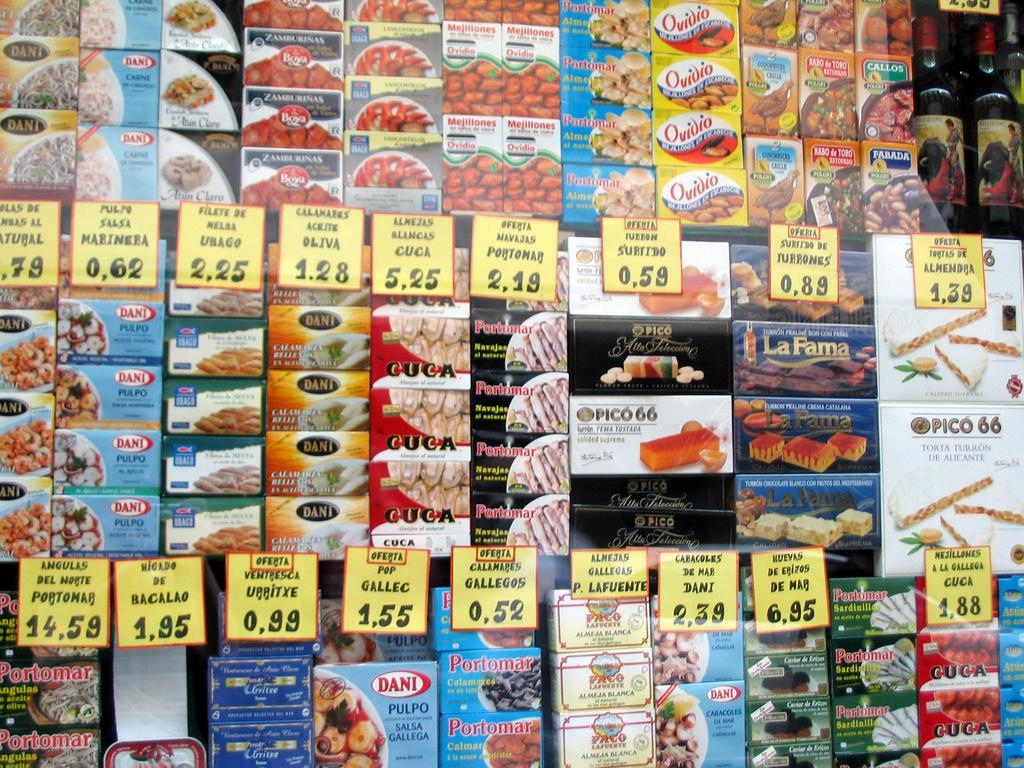What type of objects can be seen in the image? There are boxes, price tags, and jars in the image. What information can be found on the boxes? Food items are visible on the boxes, and text is present on them. What might the price tags be used for? The price tags are likely used to indicate the cost of the items. How many boats are visible in the image? There are no boats present in the image. What type of apparel is being sold in the image? There is no apparel visible in the image; it features boxes, price tags, and jars containing food items. 